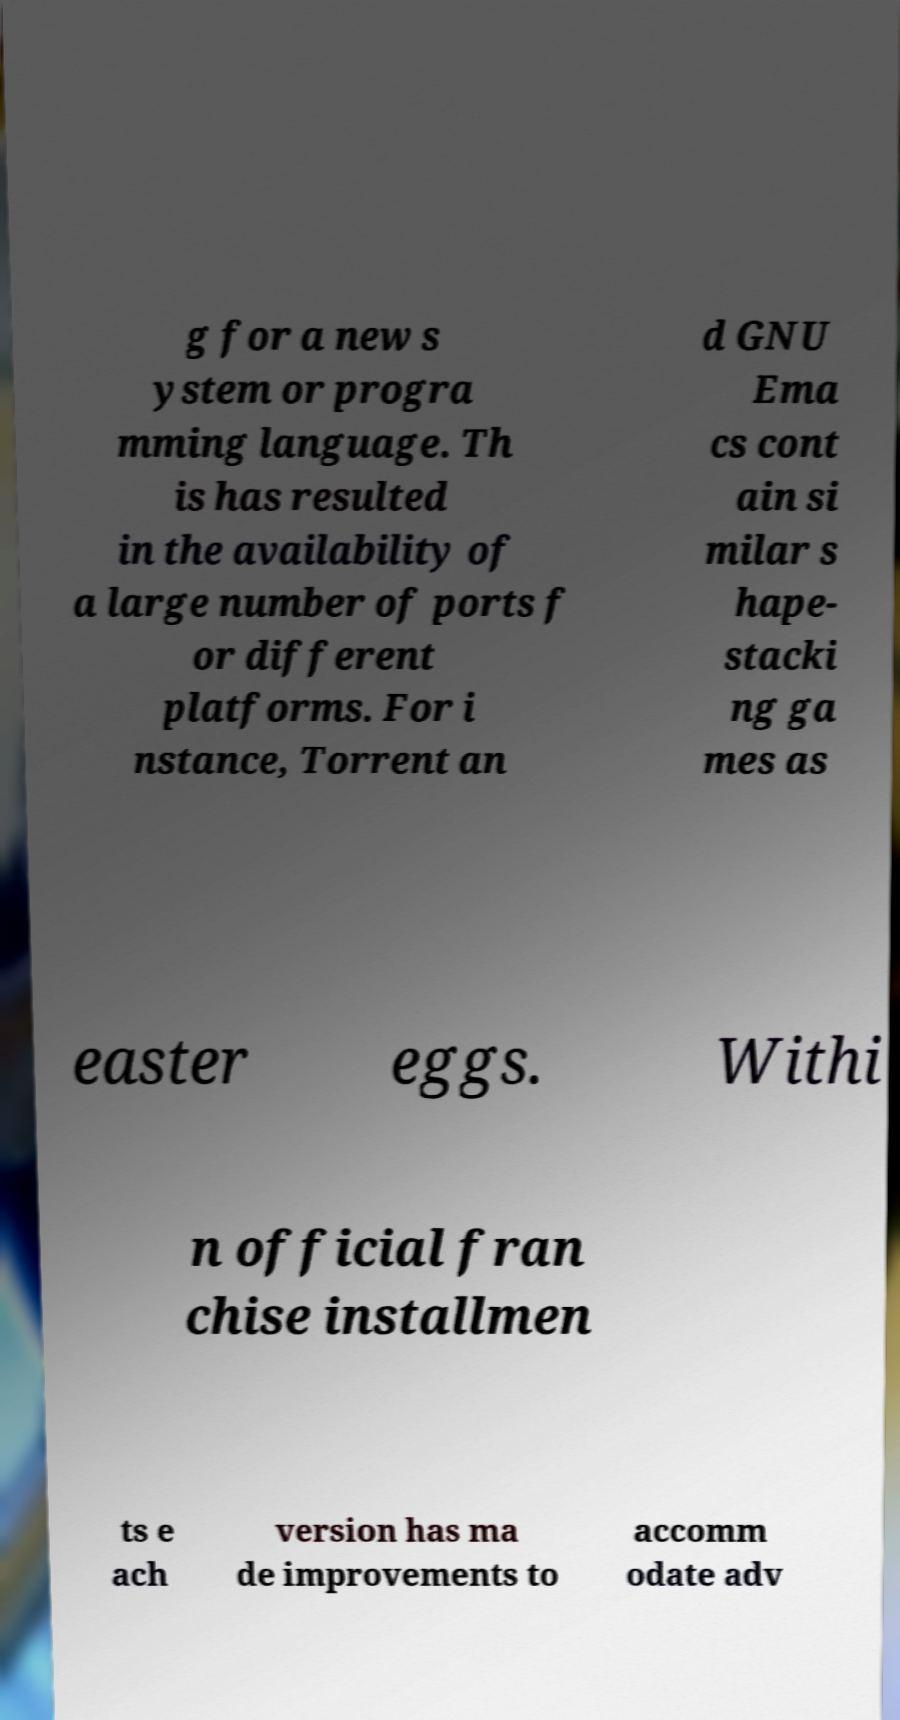For documentation purposes, I need the text within this image transcribed. Could you provide that? g for a new s ystem or progra mming language. Th is has resulted in the availability of a large number of ports f or different platforms. For i nstance, Torrent an d GNU Ema cs cont ain si milar s hape- stacki ng ga mes as easter eggs. Withi n official fran chise installmen ts e ach version has ma de improvements to accomm odate adv 